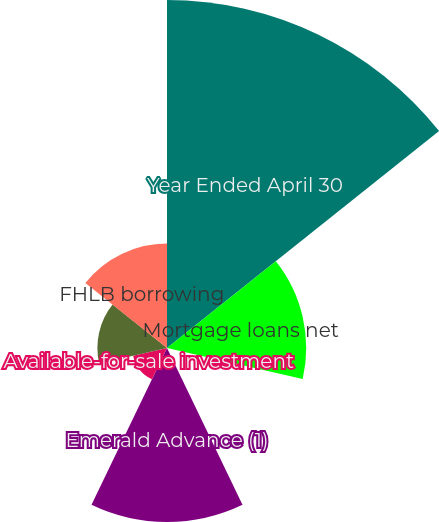Convert chart. <chart><loc_0><loc_0><loc_500><loc_500><pie_chart><fcel>Year Ended April 30<fcel>Mortgage loans net<fcel>Federal funds sold<fcel>Emerald Advance (1)<fcel>Available-for-sale investment<fcel>Customer deposits<fcel>FHLB borrowing<nl><fcel>40.0%<fcel>16.0%<fcel>0.0%<fcel>20.0%<fcel>4.0%<fcel>8.0%<fcel>12.0%<nl></chart> 